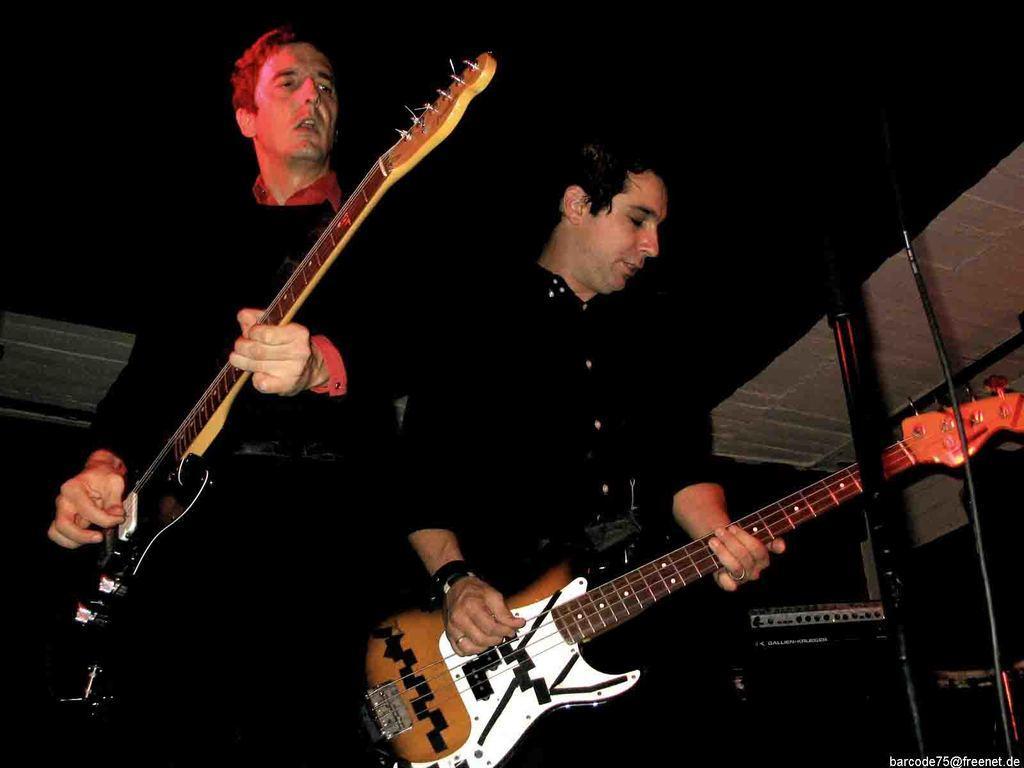In one or two sentences, can you explain what this image depicts? There are two people wearing black dresses and playing guitar in the picture. 